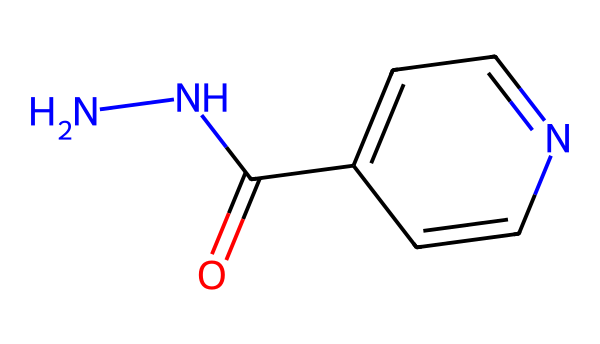What is the molecular formula of isoniazid? The SMILES representation indicates the number of each type of atom present. Counting the atoms: 6 carbon (C), 6 hydrogen (H), 4 nitrogen (N), and 1 oxygen (O), leads to the molecular formula C6H6N4O.
Answer: C6H6N4O How many nitrogen atoms are in the structure? In the provided SMILES structure, there are two distinct nitrogen atoms represented, contributing to the hydrazine functional group.
Answer: 2 What type of functional group characterizes isoniazid? The presence of the carbonyl group (C=O) adjacent to the nitrogen atoms indicates that isoniazid is characterized as a hydrazone functional group, which is key for its pharmacological activity.
Answer: hydrazone Is isoniazid classified as a hydrazine or hydrazone? Based on the structural analysis, isoniazid contains both hydrazine and hydrazone features. The initial amine group identifies it with hydrazine, while the carbonyl attachments point to it being a hydrazone.
Answer: hydrazine/hydrazone How many rings are in the chemical structure? An analysis of the structure reveals the presence of an aromatic ring within the arrangement (c1ccncc1), confirming the presence of one ring in isoniazid.
Answer: 1 What is the primary use of isoniazid? Isoniazid is primarily used in the treatment of tuberculosis (TB), which directly relates to its function as an anti-tubercular agent.
Answer: tuberculosis 